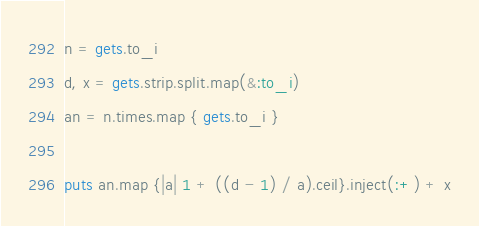Convert code to text. <code><loc_0><loc_0><loc_500><loc_500><_Ruby_>n = gets.to_i
d, x = gets.strip.split.map(&:to_i)
an = n.times.map { gets.to_i }

puts an.map {|a| 1 + ((d - 1) / a).ceil}.inject(:+) + x
</code> 